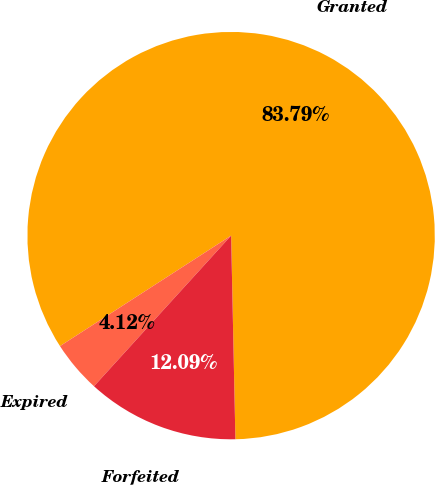Convert chart to OTSL. <chart><loc_0><loc_0><loc_500><loc_500><pie_chart><fcel>Granted<fcel>Expired<fcel>Forfeited<nl><fcel>83.79%<fcel>4.12%<fcel>12.09%<nl></chart> 